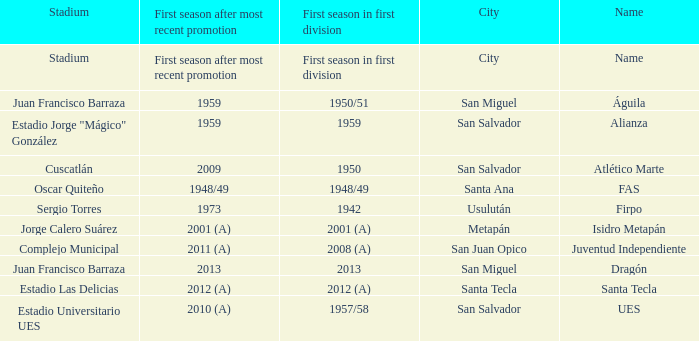Which city is Alianza? San Salvador. Would you be able to parse every entry in this table? {'header': ['Stadium', 'First season after most recent promotion', 'First season in first division', 'City', 'Name'], 'rows': [['Stadium', 'First season after most recent promotion', 'First season in first division', 'City', 'Name'], ['Juan Francisco Barraza', '1959', '1950/51', 'San Miguel', 'Águila'], ['Estadio Jorge "Mágico" González', '1959', '1959', 'San Salvador', 'Alianza'], ['Cuscatlán', '2009', '1950', 'San Salvador', 'Atlético Marte'], ['Oscar Quiteño', '1948/49', '1948/49', 'Santa Ana', 'FAS'], ['Sergio Torres', '1973', '1942', 'Usulután', 'Firpo'], ['Jorge Calero Suárez', '2001 (A)', '2001 (A)', 'Metapán', 'Isidro Metapán'], ['Complejo Municipal', '2011 (A)', '2008 (A)', 'San Juan Opico', 'Juventud Independiente'], ['Juan Francisco Barraza', '2013', '2013', 'San Miguel', 'Dragón'], ['Estadio Las Delicias', '2012 (A)', '2012 (A)', 'Santa Tecla', 'Santa Tecla'], ['Estadio Universitario UES', '2010 (A)', '1957/58', 'San Salvador', 'UES']]} 